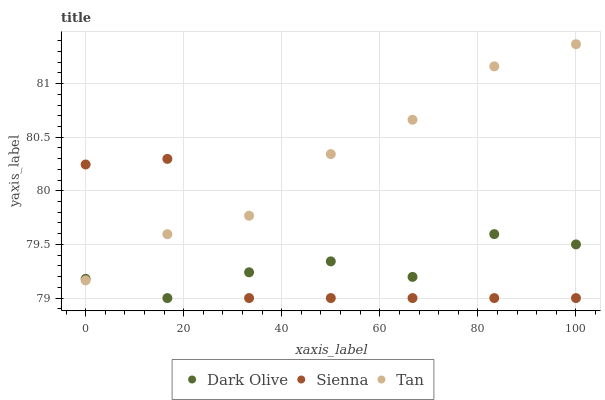Does Dark Olive have the minimum area under the curve?
Answer yes or no. Yes. Does Tan have the maximum area under the curve?
Answer yes or no. Yes. Does Tan have the minimum area under the curve?
Answer yes or no. No. Does Dark Olive have the maximum area under the curve?
Answer yes or no. No. Is Tan the smoothest?
Answer yes or no. Yes. Is Sienna the roughest?
Answer yes or no. Yes. Is Dark Olive the smoothest?
Answer yes or no. No. Is Dark Olive the roughest?
Answer yes or no. No. Does Sienna have the lowest value?
Answer yes or no. Yes. Does Tan have the lowest value?
Answer yes or no. No. Does Tan have the highest value?
Answer yes or no. Yes. Does Dark Olive have the highest value?
Answer yes or no. No. Does Sienna intersect Dark Olive?
Answer yes or no. Yes. Is Sienna less than Dark Olive?
Answer yes or no. No. Is Sienna greater than Dark Olive?
Answer yes or no. No. 